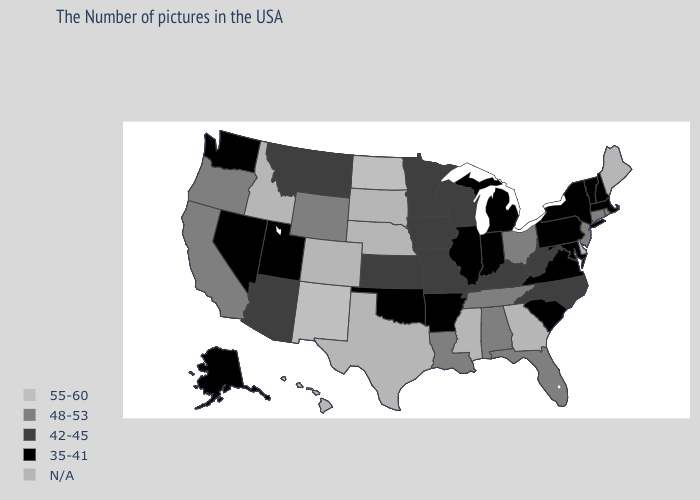What is the value of Arkansas?
Quick response, please. 35-41. Does the first symbol in the legend represent the smallest category?
Short answer required. No. How many symbols are there in the legend?
Concise answer only. 5. What is the value of Wyoming?
Write a very short answer. 48-53. Does North Dakota have the lowest value in the MidWest?
Quick response, please. No. Name the states that have a value in the range N/A?
Concise answer only. Maine, Delaware, Georgia, Mississippi, Nebraska, Texas, South Dakota, Colorado, Idaho, Hawaii. What is the highest value in the Northeast ?
Answer briefly. 48-53. Which states have the highest value in the USA?
Be succinct. North Dakota, New Mexico. What is the lowest value in the USA?
Be succinct. 35-41. What is the lowest value in the USA?
Concise answer only. 35-41. Among the states that border Washington , which have the highest value?
Quick response, please. Oregon. Name the states that have a value in the range 35-41?
Be succinct. Massachusetts, New Hampshire, Vermont, New York, Maryland, Pennsylvania, Virginia, South Carolina, Michigan, Indiana, Illinois, Arkansas, Oklahoma, Utah, Nevada, Washington, Alaska. 